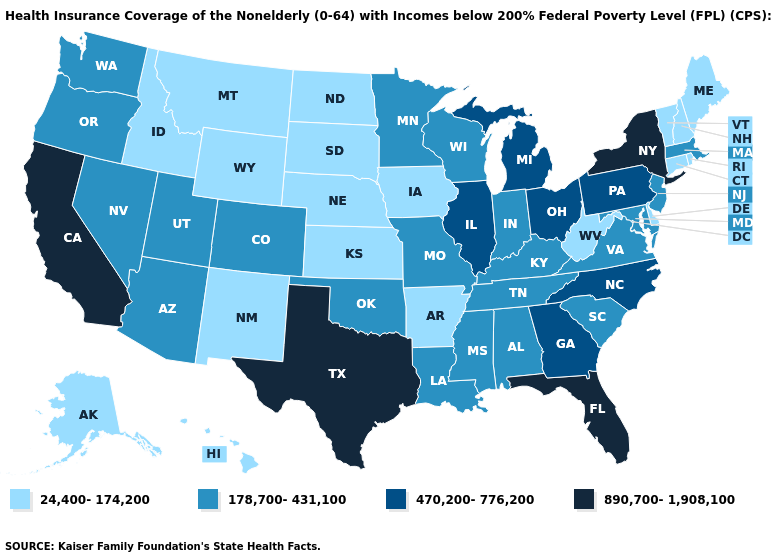What is the value of Vermont?
Short answer required. 24,400-174,200. Does Florida have the highest value in the USA?
Write a very short answer. Yes. What is the highest value in the Northeast ?
Write a very short answer. 890,700-1,908,100. Name the states that have a value in the range 178,700-431,100?
Give a very brief answer. Alabama, Arizona, Colorado, Indiana, Kentucky, Louisiana, Maryland, Massachusetts, Minnesota, Mississippi, Missouri, Nevada, New Jersey, Oklahoma, Oregon, South Carolina, Tennessee, Utah, Virginia, Washington, Wisconsin. Does Iowa have the highest value in the MidWest?
Keep it brief. No. Does Hawaii have the lowest value in the USA?
Keep it brief. Yes. Does the first symbol in the legend represent the smallest category?
Short answer required. Yes. Name the states that have a value in the range 24,400-174,200?
Keep it brief. Alaska, Arkansas, Connecticut, Delaware, Hawaii, Idaho, Iowa, Kansas, Maine, Montana, Nebraska, New Hampshire, New Mexico, North Dakota, Rhode Island, South Dakota, Vermont, West Virginia, Wyoming. Name the states that have a value in the range 890,700-1,908,100?
Give a very brief answer. California, Florida, New York, Texas. How many symbols are there in the legend?
Short answer required. 4. Does Hawaii have the same value as Vermont?
Give a very brief answer. Yes. What is the value of Nebraska?
Be succinct. 24,400-174,200. What is the lowest value in the West?
Short answer required. 24,400-174,200. Is the legend a continuous bar?
Answer briefly. No. Does Kentucky have the same value as Minnesota?
Concise answer only. Yes. 